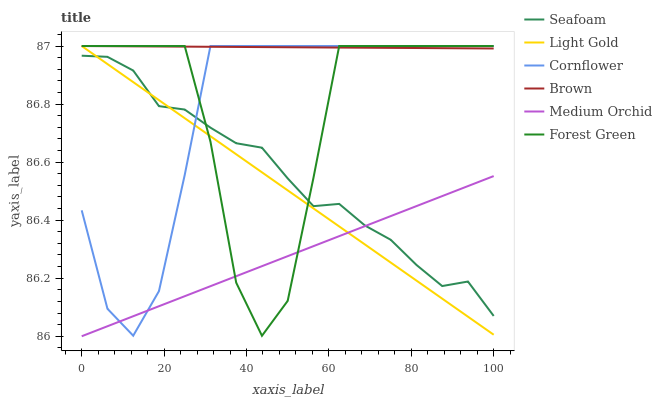Does Medium Orchid have the minimum area under the curve?
Answer yes or no. Yes. Does Brown have the maximum area under the curve?
Answer yes or no. Yes. Does Brown have the minimum area under the curve?
Answer yes or no. No. Does Medium Orchid have the maximum area under the curve?
Answer yes or no. No. Is Medium Orchid the smoothest?
Answer yes or no. Yes. Is Forest Green the roughest?
Answer yes or no. Yes. Is Brown the smoothest?
Answer yes or no. No. Is Brown the roughest?
Answer yes or no. No. Does Brown have the lowest value?
Answer yes or no. No. Does Light Gold have the highest value?
Answer yes or no. Yes. Does Medium Orchid have the highest value?
Answer yes or no. No. Is Medium Orchid less than Brown?
Answer yes or no. Yes. Is Brown greater than Medium Orchid?
Answer yes or no. Yes. Does Cornflower intersect Brown?
Answer yes or no. Yes. Is Cornflower less than Brown?
Answer yes or no. No. Is Cornflower greater than Brown?
Answer yes or no. No. Does Medium Orchid intersect Brown?
Answer yes or no. No. 